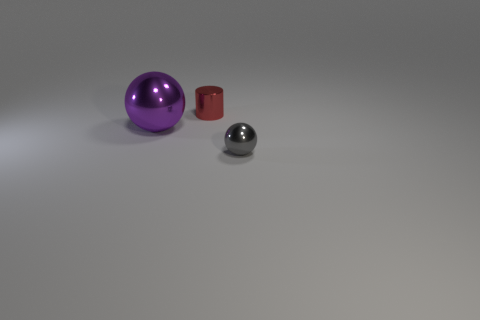Add 3 large purple metallic spheres. How many objects exist? 6 Subtract all cylinders. How many objects are left? 2 Subtract all red rubber objects. Subtract all big objects. How many objects are left? 2 Add 3 balls. How many balls are left? 5 Add 3 tiny gray metal balls. How many tiny gray metal balls exist? 4 Subtract 0 red cubes. How many objects are left? 3 